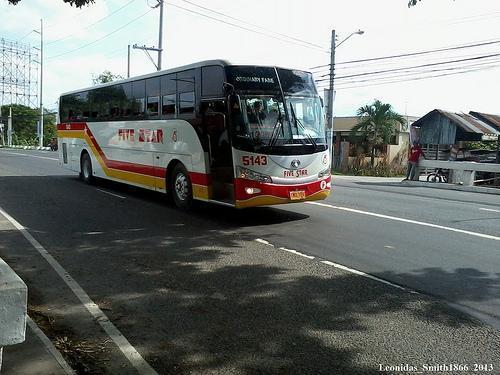How many buses are visible?
Give a very brief answer. 1. How many people are outside?
Give a very brief answer. 1. 